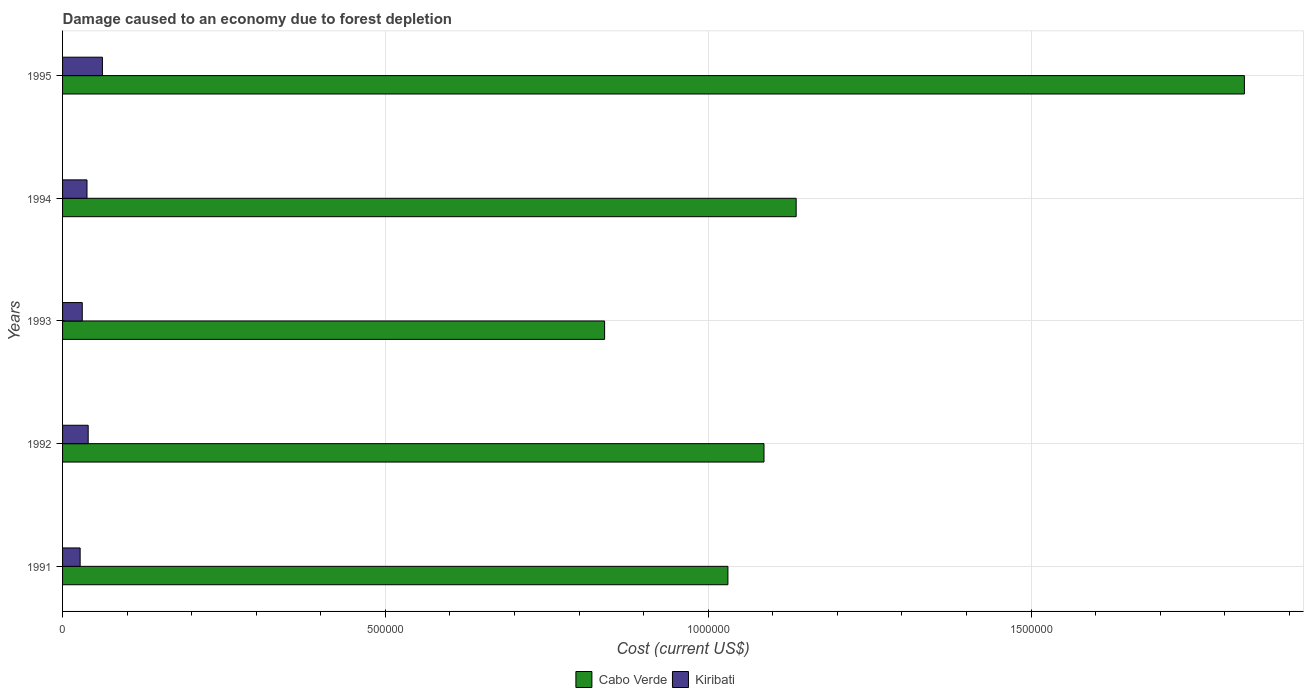How many different coloured bars are there?
Make the answer very short. 2. How many bars are there on the 1st tick from the top?
Offer a very short reply. 2. What is the label of the 2nd group of bars from the top?
Your answer should be very brief. 1994. What is the cost of damage caused due to forest depletion in Kiribati in 1992?
Offer a very short reply. 3.97e+04. Across all years, what is the maximum cost of damage caused due to forest depletion in Kiribati?
Your response must be concise. 6.17e+04. Across all years, what is the minimum cost of damage caused due to forest depletion in Cabo Verde?
Provide a succinct answer. 8.40e+05. In which year was the cost of damage caused due to forest depletion in Cabo Verde maximum?
Offer a very short reply. 1995. In which year was the cost of damage caused due to forest depletion in Kiribati minimum?
Your answer should be very brief. 1991. What is the total cost of damage caused due to forest depletion in Kiribati in the graph?
Your answer should be very brief. 1.97e+05. What is the difference between the cost of damage caused due to forest depletion in Kiribati in 1992 and that in 1995?
Keep it short and to the point. -2.20e+04. What is the difference between the cost of damage caused due to forest depletion in Cabo Verde in 1993 and the cost of damage caused due to forest depletion in Kiribati in 1994?
Your answer should be compact. 8.02e+05. What is the average cost of damage caused due to forest depletion in Cabo Verde per year?
Keep it short and to the point. 1.18e+06. In the year 1995, what is the difference between the cost of damage caused due to forest depletion in Kiribati and cost of damage caused due to forest depletion in Cabo Verde?
Ensure brevity in your answer.  -1.77e+06. In how many years, is the cost of damage caused due to forest depletion in Kiribati greater than 900000 US$?
Your answer should be compact. 0. What is the ratio of the cost of damage caused due to forest depletion in Kiribati in 1992 to that in 1994?
Keep it short and to the point. 1.05. What is the difference between the highest and the second highest cost of damage caused due to forest depletion in Kiribati?
Make the answer very short. 2.20e+04. What is the difference between the highest and the lowest cost of damage caused due to forest depletion in Kiribati?
Ensure brevity in your answer.  3.45e+04. What does the 2nd bar from the top in 1991 represents?
Give a very brief answer. Cabo Verde. What does the 1st bar from the bottom in 1991 represents?
Make the answer very short. Cabo Verde. What is the difference between two consecutive major ticks on the X-axis?
Your answer should be very brief. 5.00e+05. Does the graph contain any zero values?
Your response must be concise. No. How many legend labels are there?
Ensure brevity in your answer.  2. How are the legend labels stacked?
Ensure brevity in your answer.  Horizontal. What is the title of the graph?
Ensure brevity in your answer.  Damage caused to an economy due to forest depletion. Does "Sub-Saharan Africa (all income levels)" appear as one of the legend labels in the graph?
Give a very brief answer. No. What is the label or title of the X-axis?
Your answer should be compact. Cost (current US$). What is the label or title of the Y-axis?
Your answer should be compact. Years. What is the Cost (current US$) in Cabo Verde in 1991?
Make the answer very short. 1.03e+06. What is the Cost (current US$) of Kiribati in 1991?
Give a very brief answer. 2.72e+04. What is the Cost (current US$) of Cabo Verde in 1992?
Provide a succinct answer. 1.09e+06. What is the Cost (current US$) in Kiribati in 1992?
Your response must be concise. 3.97e+04. What is the Cost (current US$) of Cabo Verde in 1993?
Give a very brief answer. 8.40e+05. What is the Cost (current US$) of Kiribati in 1993?
Offer a terse response. 3.05e+04. What is the Cost (current US$) in Cabo Verde in 1994?
Keep it short and to the point. 1.14e+06. What is the Cost (current US$) in Kiribati in 1994?
Provide a short and direct response. 3.78e+04. What is the Cost (current US$) of Cabo Verde in 1995?
Your answer should be compact. 1.83e+06. What is the Cost (current US$) of Kiribati in 1995?
Make the answer very short. 6.17e+04. Across all years, what is the maximum Cost (current US$) in Cabo Verde?
Your answer should be compact. 1.83e+06. Across all years, what is the maximum Cost (current US$) in Kiribati?
Your answer should be very brief. 6.17e+04. Across all years, what is the minimum Cost (current US$) of Cabo Verde?
Give a very brief answer. 8.40e+05. Across all years, what is the minimum Cost (current US$) of Kiribati?
Ensure brevity in your answer.  2.72e+04. What is the total Cost (current US$) of Cabo Verde in the graph?
Keep it short and to the point. 5.92e+06. What is the total Cost (current US$) in Kiribati in the graph?
Your response must be concise. 1.97e+05. What is the difference between the Cost (current US$) of Cabo Verde in 1991 and that in 1992?
Keep it short and to the point. -5.59e+04. What is the difference between the Cost (current US$) of Kiribati in 1991 and that in 1992?
Provide a short and direct response. -1.25e+04. What is the difference between the Cost (current US$) in Cabo Verde in 1991 and that in 1993?
Give a very brief answer. 1.91e+05. What is the difference between the Cost (current US$) of Kiribati in 1991 and that in 1993?
Offer a very short reply. -3309.93. What is the difference between the Cost (current US$) in Cabo Verde in 1991 and that in 1994?
Make the answer very short. -1.06e+05. What is the difference between the Cost (current US$) in Kiribati in 1991 and that in 1994?
Give a very brief answer. -1.06e+04. What is the difference between the Cost (current US$) in Cabo Verde in 1991 and that in 1995?
Ensure brevity in your answer.  -8.00e+05. What is the difference between the Cost (current US$) in Kiribati in 1991 and that in 1995?
Ensure brevity in your answer.  -3.45e+04. What is the difference between the Cost (current US$) in Cabo Verde in 1992 and that in 1993?
Offer a very short reply. 2.47e+05. What is the difference between the Cost (current US$) of Kiribati in 1992 and that in 1993?
Provide a succinct answer. 9155.84. What is the difference between the Cost (current US$) in Cabo Verde in 1992 and that in 1994?
Provide a succinct answer. -4.98e+04. What is the difference between the Cost (current US$) in Kiribati in 1992 and that in 1994?
Your response must be concise. 1835.73. What is the difference between the Cost (current US$) in Cabo Verde in 1992 and that in 1995?
Keep it short and to the point. -7.44e+05. What is the difference between the Cost (current US$) in Kiribati in 1992 and that in 1995?
Ensure brevity in your answer.  -2.20e+04. What is the difference between the Cost (current US$) in Cabo Verde in 1993 and that in 1994?
Offer a terse response. -2.97e+05. What is the difference between the Cost (current US$) in Kiribati in 1993 and that in 1994?
Give a very brief answer. -7320.1. What is the difference between the Cost (current US$) in Cabo Verde in 1993 and that in 1995?
Provide a succinct answer. -9.91e+05. What is the difference between the Cost (current US$) in Kiribati in 1993 and that in 1995?
Provide a short and direct response. -3.12e+04. What is the difference between the Cost (current US$) of Cabo Verde in 1994 and that in 1995?
Your response must be concise. -6.94e+05. What is the difference between the Cost (current US$) in Kiribati in 1994 and that in 1995?
Your answer should be very brief. -2.39e+04. What is the difference between the Cost (current US$) of Cabo Verde in 1991 and the Cost (current US$) of Kiribati in 1992?
Make the answer very short. 9.91e+05. What is the difference between the Cost (current US$) in Cabo Verde in 1991 and the Cost (current US$) in Kiribati in 1993?
Offer a terse response. 1.00e+06. What is the difference between the Cost (current US$) in Cabo Verde in 1991 and the Cost (current US$) in Kiribati in 1994?
Provide a succinct answer. 9.93e+05. What is the difference between the Cost (current US$) of Cabo Verde in 1991 and the Cost (current US$) of Kiribati in 1995?
Provide a short and direct response. 9.69e+05. What is the difference between the Cost (current US$) in Cabo Verde in 1992 and the Cost (current US$) in Kiribati in 1993?
Offer a terse response. 1.06e+06. What is the difference between the Cost (current US$) in Cabo Verde in 1992 and the Cost (current US$) in Kiribati in 1994?
Your response must be concise. 1.05e+06. What is the difference between the Cost (current US$) in Cabo Verde in 1992 and the Cost (current US$) in Kiribati in 1995?
Provide a succinct answer. 1.02e+06. What is the difference between the Cost (current US$) of Cabo Verde in 1993 and the Cost (current US$) of Kiribati in 1994?
Give a very brief answer. 8.02e+05. What is the difference between the Cost (current US$) of Cabo Verde in 1993 and the Cost (current US$) of Kiribati in 1995?
Your answer should be very brief. 7.78e+05. What is the difference between the Cost (current US$) in Cabo Verde in 1994 and the Cost (current US$) in Kiribati in 1995?
Provide a succinct answer. 1.07e+06. What is the average Cost (current US$) in Cabo Verde per year?
Your answer should be very brief. 1.18e+06. What is the average Cost (current US$) in Kiribati per year?
Your response must be concise. 3.94e+04. In the year 1991, what is the difference between the Cost (current US$) of Cabo Verde and Cost (current US$) of Kiribati?
Give a very brief answer. 1.00e+06. In the year 1992, what is the difference between the Cost (current US$) of Cabo Verde and Cost (current US$) of Kiribati?
Provide a short and direct response. 1.05e+06. In the year 1993, what is the difference between the Cost (current US$) of Cabo Verde and Cost (current US$) of Kiribati?
Give a very brief answer. 8.09e+05. In the year 1994, what is the difference between the Cost (current US$) of Cabo Verde and Cost (current US$) of Kiribati?
Your answer should be compact. 1.10e+06. In the year 1995, what is the difference between the Cost (current US$) in Cabo Verde and Cost (current US$) in Kiribati?
Keep it short and to the point. 1.77e+06. What is the ratio of the Cost (current US$) in Cabo Verde in 1991 to that in 1992?
Your response must be concise. 0.95. What is the ratio of the Cost (current US$) of Kiribati in 1991 to that in 1992?
Make the answer very short. 0.69. What is the ratio of the Cost (current US$) in Cabo Verde in 1991 to that in 1993?
Make the answer very short. 1.23. What is the ratio of the Cost (current US$) of Kiribati in 1991 to that in 1993?
Your response must be concise. 0.89. What is the ratio of the Cost (current US$) in Cabo Verde in 1991 to that in 1994?
Your answer should be very brief. 0.91. What is the ratio of the Cost (current US$) of Kiribati in 1991 to that in 1994?
Offer a very short reply. 0.72. What is the ratio of the Cost (current US$) in Cabo Verde in 1991 to that in 1995?
Make the answer very short. 0.56. What is the ratio of the Cost (current US$) of Kiribati in 1991 to that in 1995?
Give a very brief answer. 0.44. What is the ratio of the Cost (current US$) in Cabo Verde in 1992 to that in 1993?
Your response must be concise. 1.29. What is the ratio of the Cost (current US$) of Cabo Verde in 1992 to that in 1994?
Give a very brief answer. 0.96. What is the ratio of the Cost (current US$) in Kiribati in 1992 to that in 1994?
Keep it short and to the point. 1.05. What is the ratio of the Cost (current US$) in Cabo Verde in 1992 to that in 1995?
Offer a terse response. 0.59. What is the ratio of the Cost (current US$) of Kiribati in 1992 to that in 1995?
Provide a short and direct response. 0.64. What is the ratio of the Cost (current US$) in Cabo Verde in 1993 to that in 1994?
Your answer should be very brief. 0.74. What is the ratio of the Cost (current US$) of Kiribati in 1993 to that in 1994?
Make the answer very short. 0.81. What is the ratio of the Cost (current US$) of Cabo Verde in 1993 to that in 1995?
Give a very brief answer. 0.46. What is the ratio of the Cost (current US$) of Kiribati in 1993 to that in 1995?
Give a very brief answer. 0.49. What is the ratio of the Cost (current US$) in Cabo Verde in 1994 to that in 1995?
Provide a short and direct response. 0.62. What is the ratio of the Cost (current US$) in Kiribati in 1994 to that in 1995?
Provide a short and direct response. 0.61. What is the difference between the highest and the second highest Cost (current US$) of Cabo Verde?
Your answer should be very brief. 6.94e+05. What is the difference between the highest and the second highest Cost (current US$) in Kiribati?
Offer a very short reply. 2.20e+04. What is the difference between the highest and the lowest Cost (current US$) of Cabo Verde?
Provide a short and direct response. 9.91e+05. What is the difference between the highest and the lowest Cost (current US$) in Kiribati?
Make the answer very short. 3.45e+04. 